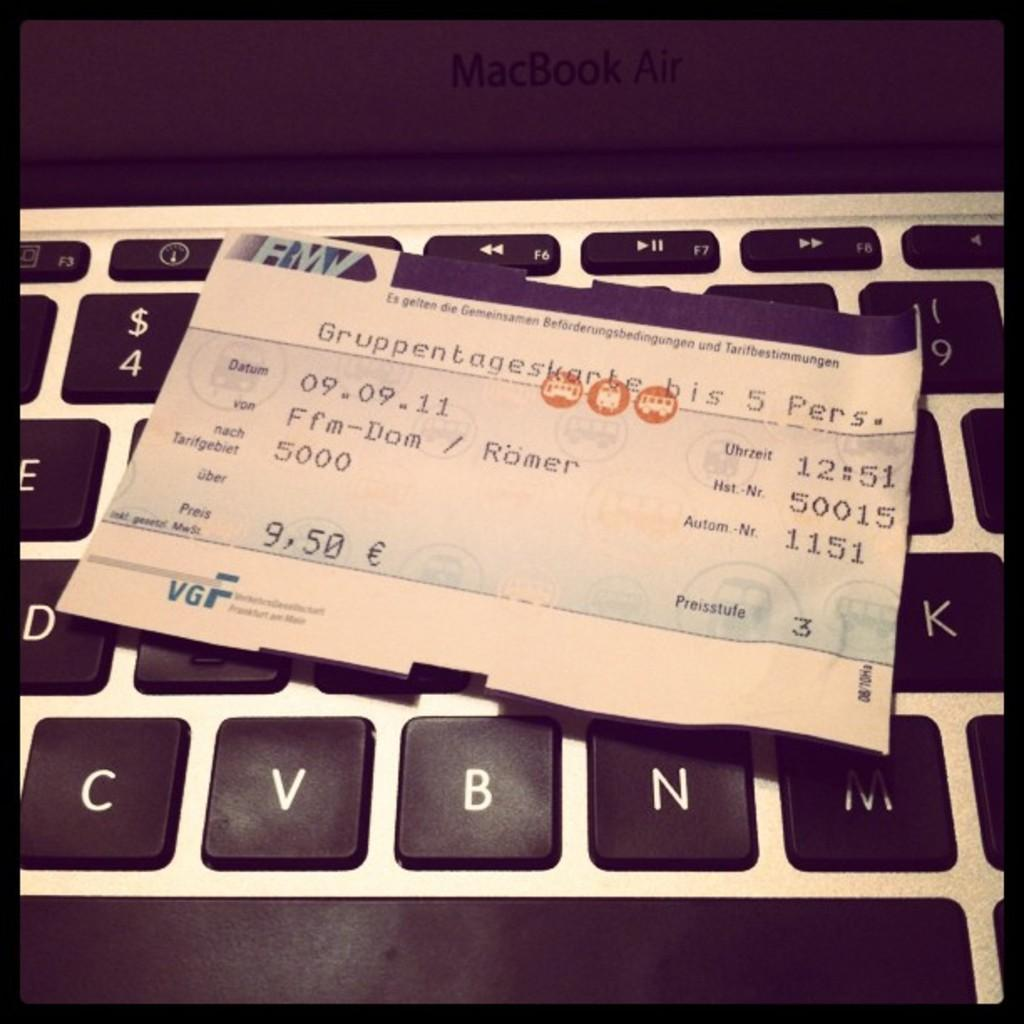<image>
Provide a brief description of the given image. A boarding pass has the initials VGF on it. 